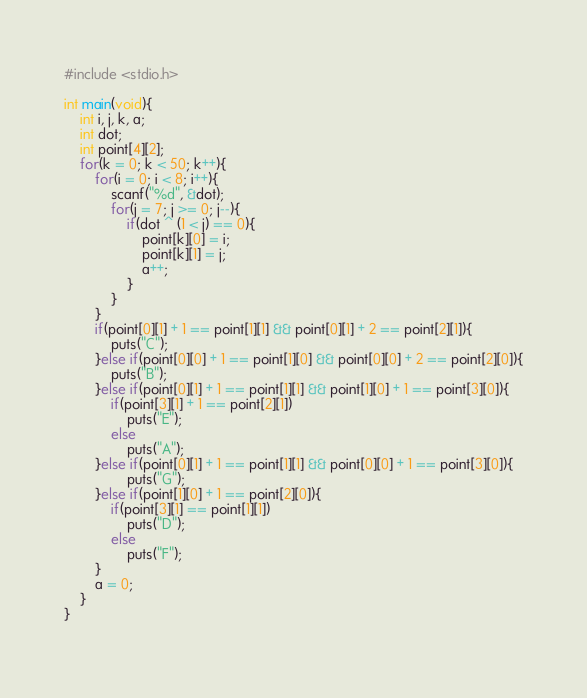Convert code to text. <code><loc_0><loc_0><loc_500><loc_500><_C_>#include <stdio.h>

int main(void){
    int i, j, k, a;
    int dot;
    int point[4][2];
    for(k = 0; k < 50; k++){
        for(i = 0; i < 8; i++){
            scanf("%d", &dot);
            for(j = 7; j >= 0; j--){
                if(dot ^ (1 < j) == 0){
                    point[k][0] = i;
                    point[k][1] = j;
                    a++;
                }
            }
        }
        if(point[0][1] + 1 == point[1][1] && point[0][1] + 2 == point[2][1]){
            puts("C");
        }else if(point[0][0] + 1 == point[1][0] && point[0][0] + 2 == point[2][0]){
            puts("B");
        }else if(point[0][1] + 1 == point[1][1] && point[1][0] + 1 == point[3][0]){
            if(point[3][1] + 1 == point[2][1])
                puts("E");
            else
                puts("A");
        }else if(point[0][1] + 1 == point[1][1] && point[0][0] + 1 == point[3][0]){
                puts("G");
        }else if(point[1][0] + 1 == point[2][0]){
            if(point[3][1] == point[1][1])
                puts("D");
            else
                puts("F");
        }
        a = 0;
    }
}
           </code> 